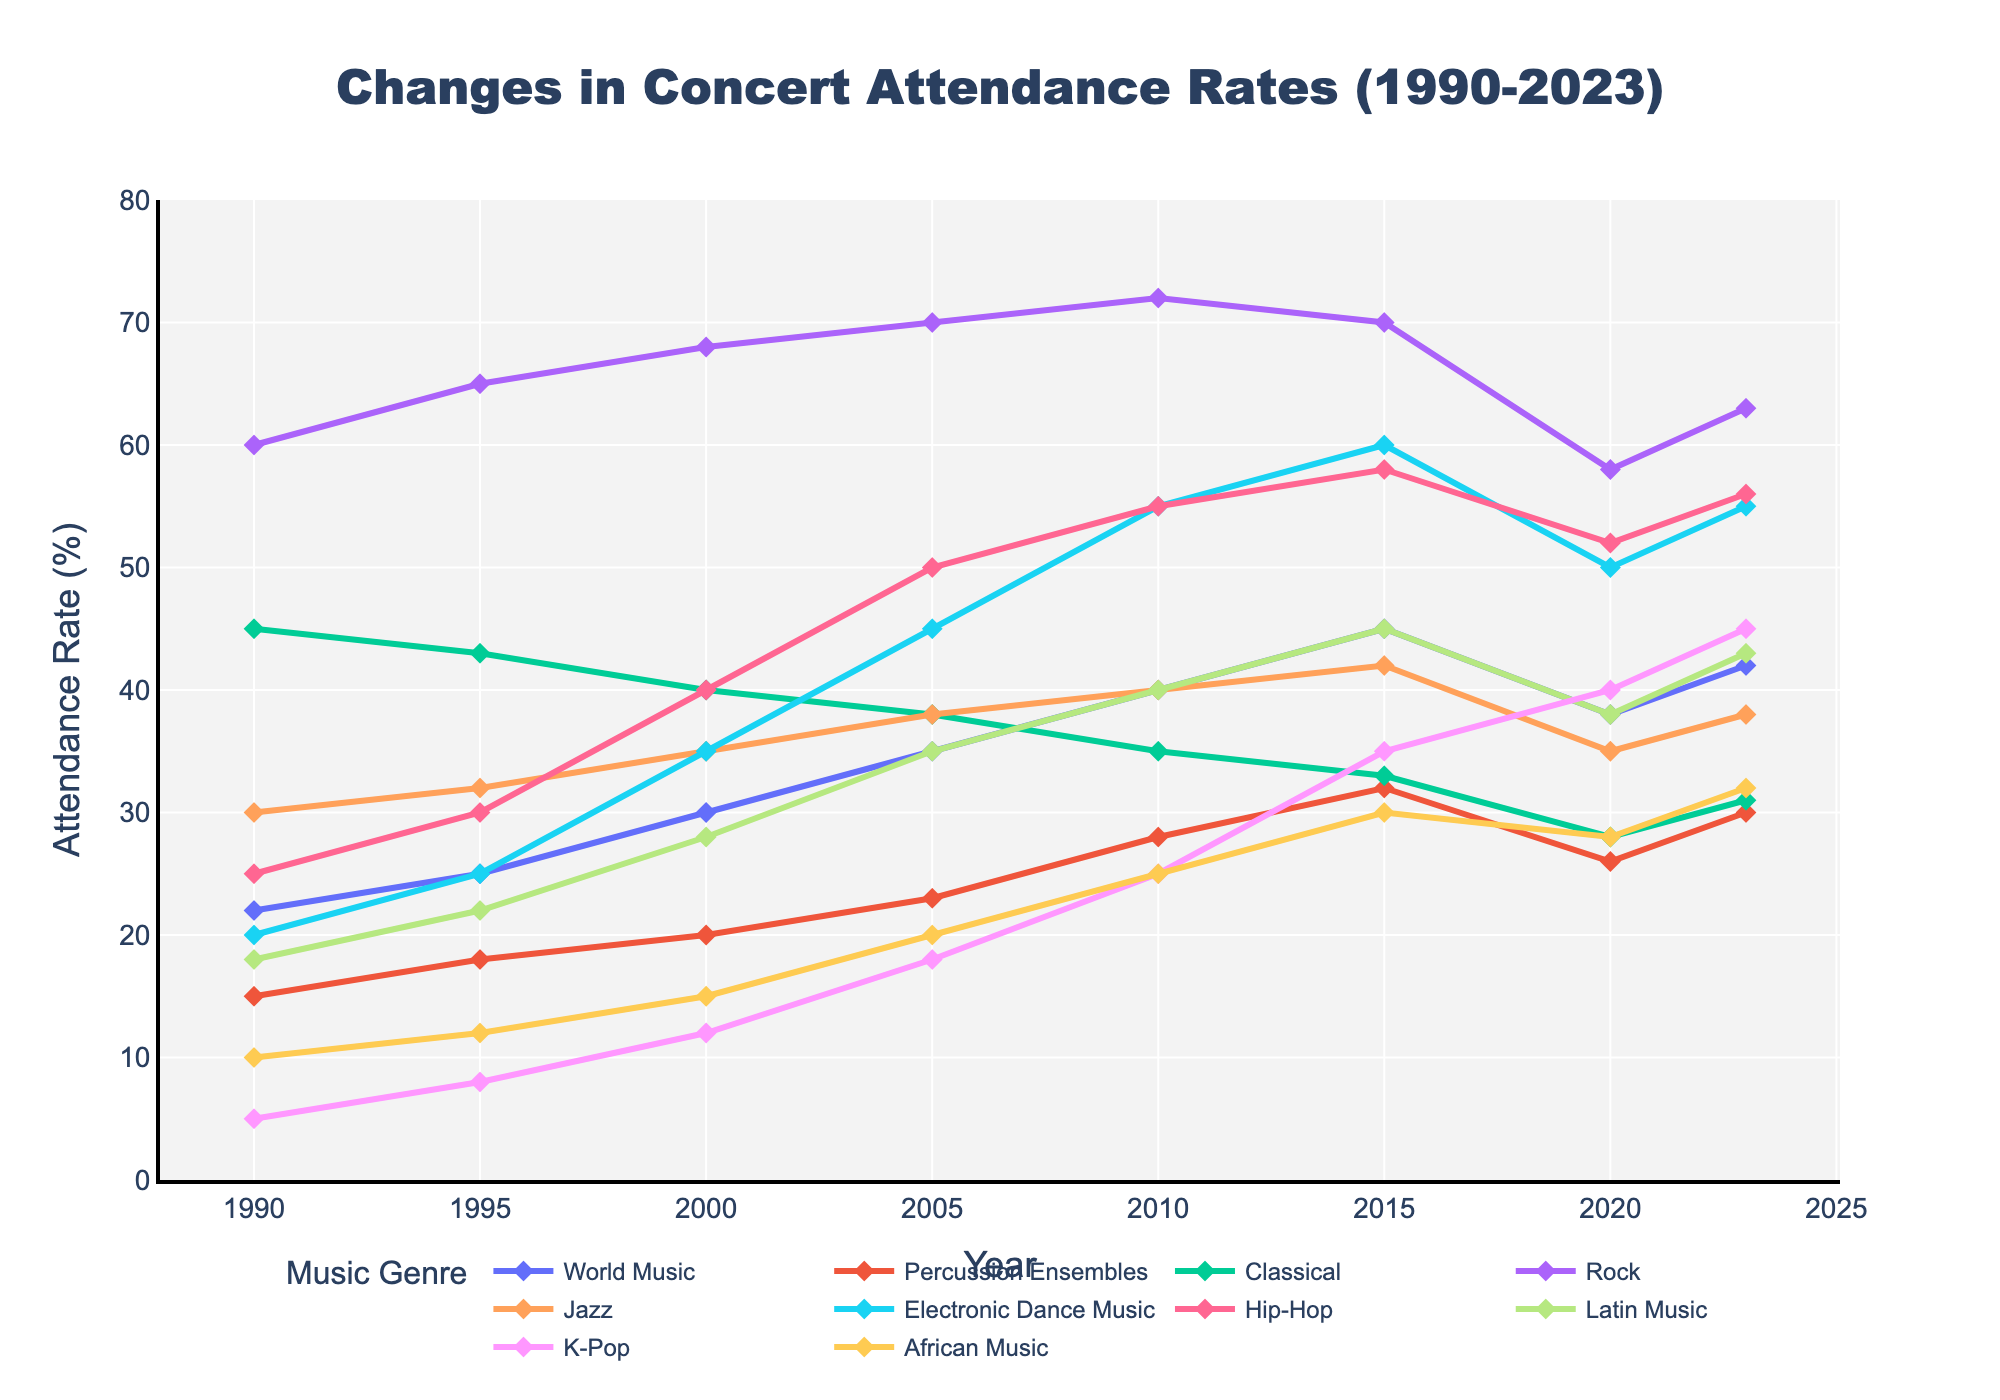Which genre had the highest attendance rate in 2023? Look at the value corresponding to 2023 for each musical genre. The highest point is for K-Pop.
Answer: K-Pop How did the attendance rate for Classical music change from 1990 to 2023? Find the values for Classical music in 1990 and 2023. The value in 1990 is 45%, and in 2023, it is 31%. The change is 45% - 31%, which is a decrease of 14%.
Answer: Decreased by 14% Which two genres had the most similar attendance rates in 2020? Compare the values for all genres in 2020. Percussion Ensembles and Latin Music both have values around 38%.
Answer: Percussion Ensembles and Latin Music What is the average attendance rate for Jazz music from 1990 to 2023? Sum the values for Jazz music (30, 32, 35, 38, 40, 42, 35, 38) and divide by the number of years (8). The sum is 290, and the average is 290/8.
Answer: 36.25% By how much did the attendance rate for Electronic Dance Music increase from 1990 to 2015? Check the values for Electronic Dance Music in 1990 and 2015. In 1990, the value is 20%, and in 2015, it is 60%. The increase is 60% - 20% = 40%.
Answer: Increased by 40% Which genre had the steepest decline in attendance rate between 2015 and 2020? Compare the decrease from 2015 to 2020 for all genres. Rock decreased from 70% to 58%, which is a decline of 12%, the largest among the genres.
Answer: Rock What is the total increase in attendance rate for K-Pop from 1990 to 2023? Find the values for K-Pop in 1990 and 2023. In 1990, it is 5%, and 45% in 2023. The total increase is 45% - 5% = 40%.
Answer: 40% Which genre experienced a decline in attendance rate between 2015 and 2020, but an increase by 2023? Look at the trends from 2015 to 2020, and then to 2023. World Music fits this pattern, decreasing from 45% to 38%, then increasing to 42%.
Answer: World Music 